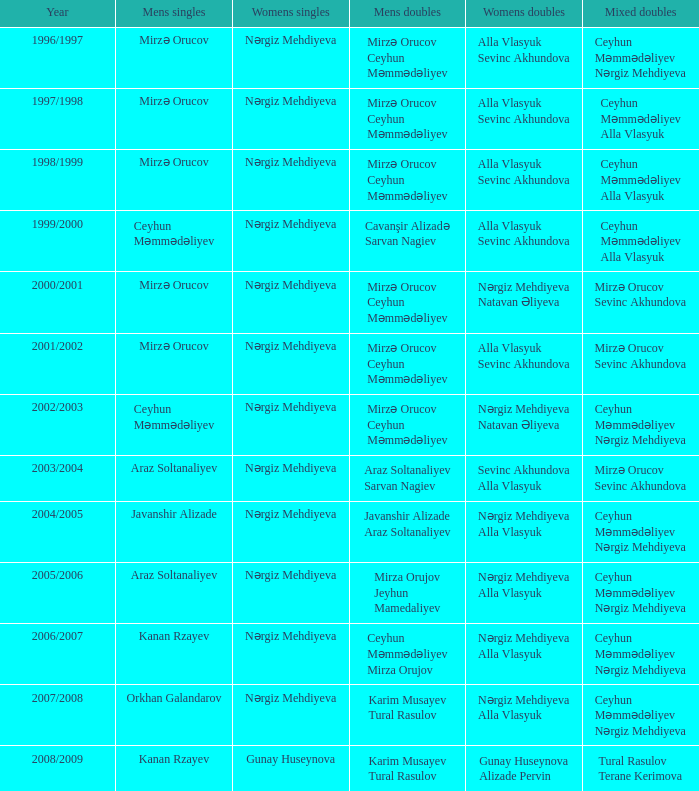Who are all the ladies' doubles for the year 2008/2009? Gunay Huseynova Alizade Pervin. I'm looking to parse the entire table for insights. Could you assist me with that? {'header': ['Year', 'Mens singles', 'Womens singles', 'Mens doubles', 'Womens doubles', 'Mixed doubles'], 'rows': [['1996/1997', 'Mirzə Orucov', 'Nərgiz Mehdiyeva', 'Mirzə Orucov Ceyhun Məmmədəliyev', 'Alla Vlasyuk Sevinc Akhundova', 'Ceyhun Məmmədəliyev Nərgiz Mehdiyeva'], ['1997/1998', 'Mirzə Orucov', 'Nərgiz Mehdiyeva', 'Mirzə Orucov Ceyhun Məmmədəliyev', 'Alla Vlasyuk Sevinc Akhundova', 'Ceyhun Məmmədəliyev Alla Vlasyuk'], ['1998/1999', 'Mirzə Orucov', 'Nərgiz Mehdiyeva', 'Mirzə Orucov Ceyhun Məmmədəliyev', 'Alla Vlasyuk Sevinc Akhundova', 'Ceyhun Məmmədəliyev Alla Vlasyuk'], ['1999/2000', 'Ceyhun Məmmədəliyev', 'Nərgiz Mehdiyeva', 'Cavanşir Alizadə Sarvan Nagiev', 'Alla Vlasyuk Sevinc Akhundova', 'Ceyhun Məmmədəliyev Alla Vlasyuk'], ['2000/2001', 'Mirzə Orucov', 'Nərgiz Mehdiyeva', 'Mirzə Orucov Ceyhun Məmmədəliyev', 'Nərgiz Mehdiyeva Natavan Əliyeva', 'Mirzə Orucov Sevinc Akhundova'], ['2001/2002', 'Mirzə Orucov', 'Nərgiz Mehdiyeva', 'Mirzə Orucov Ceyhun Məmmədəliyev', 'Alla Vlasyuk Sevinc Akhundova', 'Mirzə Orucov Sevinc Akhundova'], ['2002/2003', 'Ceyhun Məmmədəliyev', 'Nərgiz Mehdiyeva', 'Mirzə Orucov Ceyhun Məmmədəliyev', 'Nərgiz Mehdiyeva Natavan Əliyeva', 'Ceyhun Məmmədəliyev Nərgiz Mehdiyeva'], ['2003/2004', 'Araz Soltanaliyev', 'Nərgiz Mehdiyeva', 'Araz Soltanaliyev Sarvan Nagiev', 'Sevinc Akhundova Alla Vlasyuk', 'Mirzə Orucov Sevinc Akhundova'], ['2004/2005', 'Javanshir Alizade', 'Nərgiz Mehdiyeva', 'Javanshir Alizade Araz Soltanaliyev', 'Nərgiz Mehdiyeva Alla Vlasyuk', 'Ceyhun Məmmədəliyev Nərgiz Mehdiyeva'], ['2005/2006', 'Araz Soltanaliyev', 'Nərgiz Mehdiyeva', 'Mirza Orujov Jeyhun Mamedaliyev', 'Nərgiz Mehdiyeva Alla Vlasyuk', 'Ceyhun Məmmədəliyev Nərgiz Mehdiyeva'], ['2006/2007', 'Kanan Rzayev', 'Nərgiz Mehdiyeva', 'Ceyhun Məmmədəliyev Mirza Orujov', 'Nərgiz Mehdiyeva Alla Vlasyuk', 'Ceyhun Məmmədəliyev Nərgiz Mehdiyeva'], ['2007/2008', 'Orkhan Galandarov', 'Nərgiz Mehdiyeva', 'Karim Musayev Tural Rasulov', 'Nərgiz Mehdiyeva Alla Vlasyuk', 'Ceyhun Məmmədəliyev Nərgiz Mehdiyeva'], ['2008/2009', 'Kanan Rzayev', 'Gunay Huseynova', 'Karim Musayev Tural Rasulov', 'Gunay Huseynova Alizade Pervin', 'Tural Rasulov Terane Kerimova']]} 